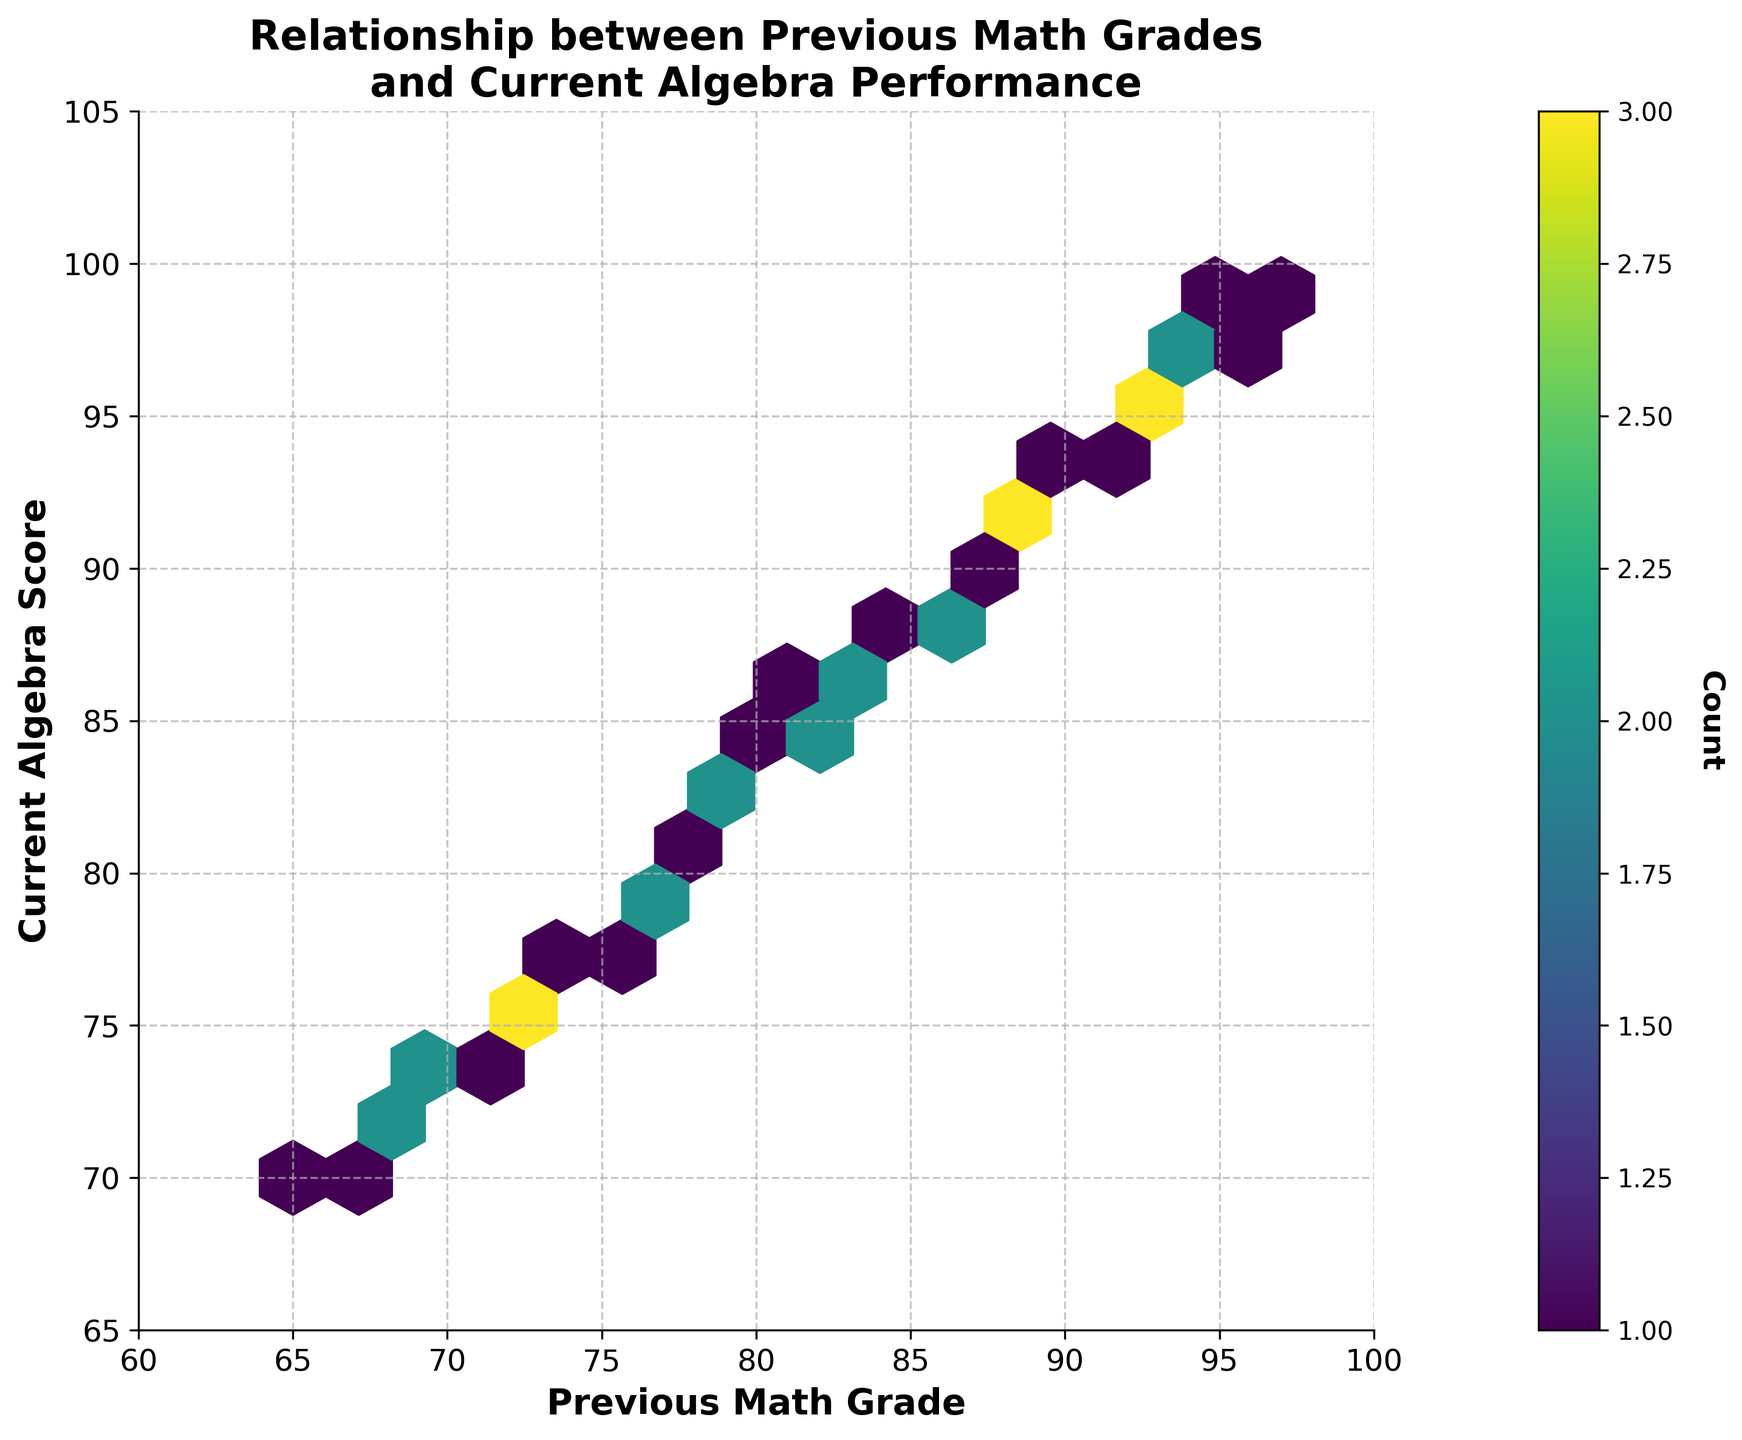What is the title of the plot? The plot's title is displayed at the top of the figure. It clearly describes the data being visualized.
Answer: Relationship between Previous Math Grades and Current Algebra Performance What are the labels on the x and y axes? The labels for the x and y axes are written beside them, explaining what each axis represents.
Answer: Previous Math Grade (x-axis), Current Algebra Score (y-axis) What color scheme is used in the hexbin plot? The color scheme appears as various shades of a single color, used to represent different data densities. The exact color can be inferred from the visual appearance.
Answer: Viridis (shades of green to yellow) How many bins have the highest density of data points? The highest density of data points can be identified by looking for the bins that are most intensely colored in the plot.
Answer: One What is the approximate range of the current algebra scores? The y-axis shows the range of current algebra scores based on the ticks and limits defined on the axis.
Answer: 65 to 105 Is there a positive correlation between previous math grades and current algebra scores? There is a visible trend in the hexbin plot where higher previous math grades correspond to higher current algebra scores, forming a roughly diagonal pattern from the bottom-left to the top-right.
Answer: Yes Which grade range shows the highest concentration of data points? The area with the most intensely colored hexagons indicates the grade range with the highest concentration of data points. This can be identified by locating this area on the x-axis and y-axis.
Answer: Around 80 to 90 for both previous math grades and current algebra scores What does the hexagonal binning method tell us about the spread of the data? The hexagonal binning method groups data points into hexagons and uses color to indicate data density, allowing a visual assessment of how tightly clustered or spread out the data points are.
Answer: It shows that data points are moderately spread out but with higher concentrations in certain grade ranges How does the distribution of student performances change as previous math grades increase? Observing the progression of data densities from lower to higher previous math grades on the x-axis helps assess whether higher grades result in similarly higher algebra scores.
Answer: The distribution shifts upward, indicating an increase in current algebra scores with higher previous math grades Would you say the relationship between previous math grades and current algebra scores is linear? The overall pattern of the hexbin plot, with data points forming a line-like distribution from bottom-left to top-right, suggests a linear relationship between the two variables.
Answer: Yes 